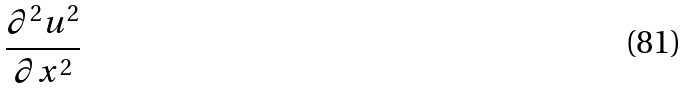Convert formula to latex. <formula><loc_0><loc_0><loc_500><loc_500>\frac { \partial ^ { 2 } u ^ { 2 } } { \partial x ^ { 2 } }</formula> 